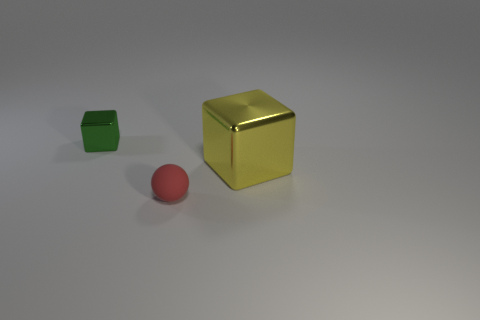Add 2 green rubber cubes. How many objects exist? 5 Subtract all blocks. How many objects are left? 1 Add 1 yellow blocks. How many yellow blocks exist? 2 Subtract 1 yellow blocks. How many objects are left? 2 Subtract all big cubes. Subtract all blocks. How many objects are left? 0 Add 1 large yellow things. How many large yellow things are left? 2 